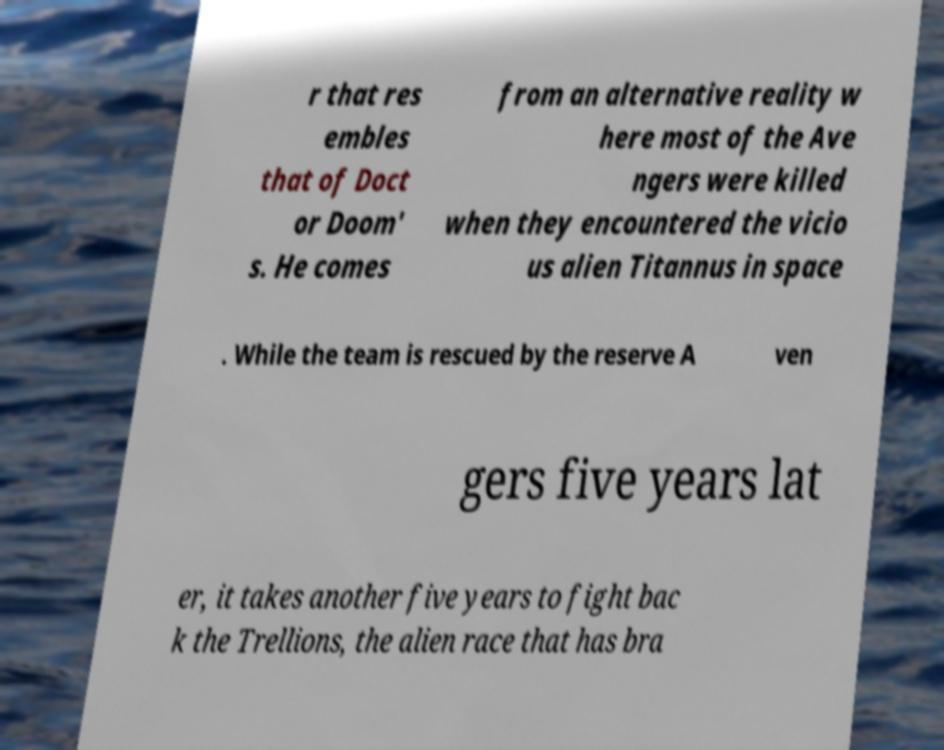What messages or text are displayed in this image? I need them in a readable, typed format. r that res embles that of Doct or Doom' s. He comes from an alternative reality w here most of the Ave ngers were killed when they encountered the vicio us alien Titannus in space . While the team is rescued by the reserve A ven gers five years lat er, it takes another five years to fight bac k the Trellions, the alien race that has bra 